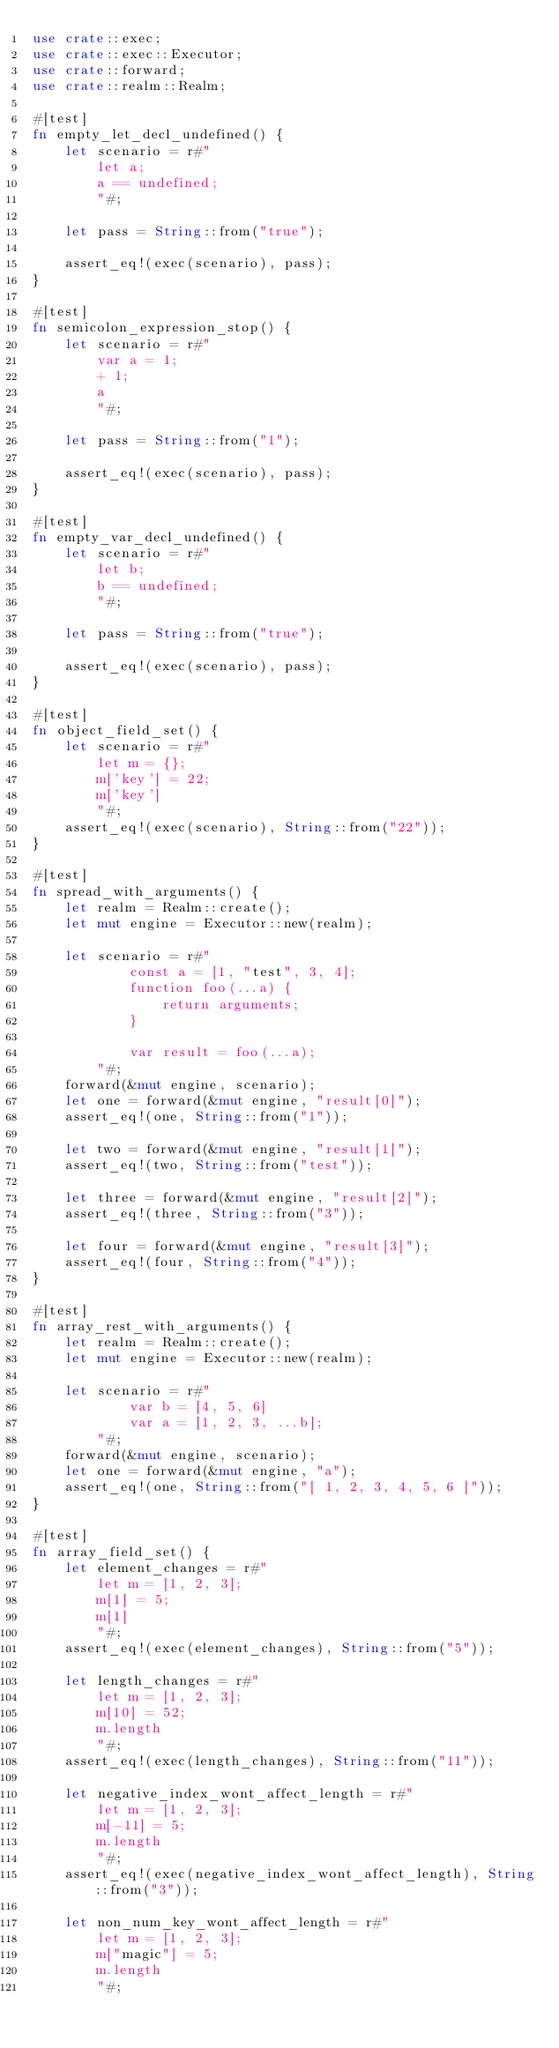<code> <loc_0><loc_0><loc_500><loc_500><_Rust_>use crate::exec;
use crate::exec::Executor;
use crate::forward;
use crate::realm::Realm;

#[test]
fn empty_let_decl_undefined() {
    let scenario = r#"
        let a;
        a == undefined;
        "#;

    let pass = String::from("true");

    assert_eq!(exec(scenario), pass);
}

#[test]
fn semicolon_expression_stop() {
    let scenario = r#"
        var a = 1;
        + 1;
        a
        "#;

    let pass = String::from("1");

    assert_eq!(exec(scenario), pass);
}

#[test]
fn empty_var_decl_undefined() {
    let scenario = r#"
        let b;
        b == undefined;
        "#;

    let pass = String::from("true");

    assert_eq!(exec(scenario), pass);
}

#[test]
fn object_field_set() {
    let scenario = r#"
        let m = {};
        m['key'] = 22;
        m['key']
        "#;
    assert_eq!(exec(scenario), String::from("22"));
}

#[test]
fn spread_with_arguments() {
    let realm = Realm::create();
    let mut engine = Executor::new(realm);

    let scenario = r#"
            const a = [1, "test", 3, 4];
            function foo(...a) {
                return arguments;
            }

            var result = foo(...a);
        "#;
    forward(&mut engine, scenario);
    let one = forward(&mut engine, "result[0]");
    assert_eq!(one, String::from("1"));

    let two = forward(&mut engine, "result[1]");
    assert_eq!(two, String::from("test"));

    let three = forward(&mut engine, "result[2]");
    assert_eq!(three, String::from("3"));

    let four = forward(&mut engine, "result[3]");
    assert_eq!(four, String::from("4"));
}

#[test]
fn array_rest_with_arguments() {
    let realm = Realm::create();
    let mut engine = Executor::new(realm);

    let scenario = r#"
            var b = [4, 5, 6]
            var a = [1, 2, 3, ...b];
        "#;
    forward(&mut engine, scenario);
    let one = forward(&mut engine, "a");
    assert_eq!(one, String::from("[ 1, 2, 3, 4, 5, 6 ]"));
}

#[test]
fn array_field_set() {
    let element_changes = r#"
        let m = [1, 2, 3];
        m[1] = 5;
        m[1]
        "#;
    assert_eq!(exec(element_changes), String::from("5"));

    let length_changes = r#"
        let m = [1, 2, 3];
        m[10] = 52;
        m.length
        "#;
    assert_eq!(exec(length_changes), String::from("11"));

    let negative_index_wont_affect_length = r#"
        let m = [1, 2, 3];
        m[-11] = 5;
        m.length
        "#;
    assert_eq!(exec(negative_index_wont_affect_length), String::from("3"));

    let non_num_key_wont_affect_length = r#"
        let m = [1, 2, 3];
        m["magic"] = 5;
        m.length
        "#;</code> 